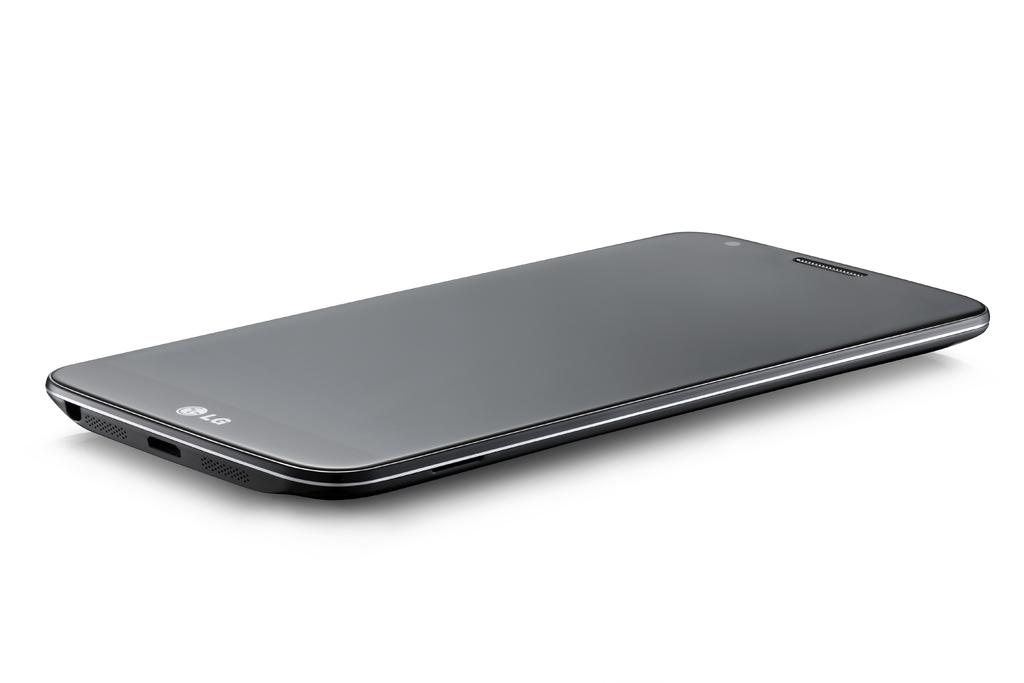<image>
Offer a succinct explanation of the picture presented. A black LG cell phone lies on its face on a blank white surface. 